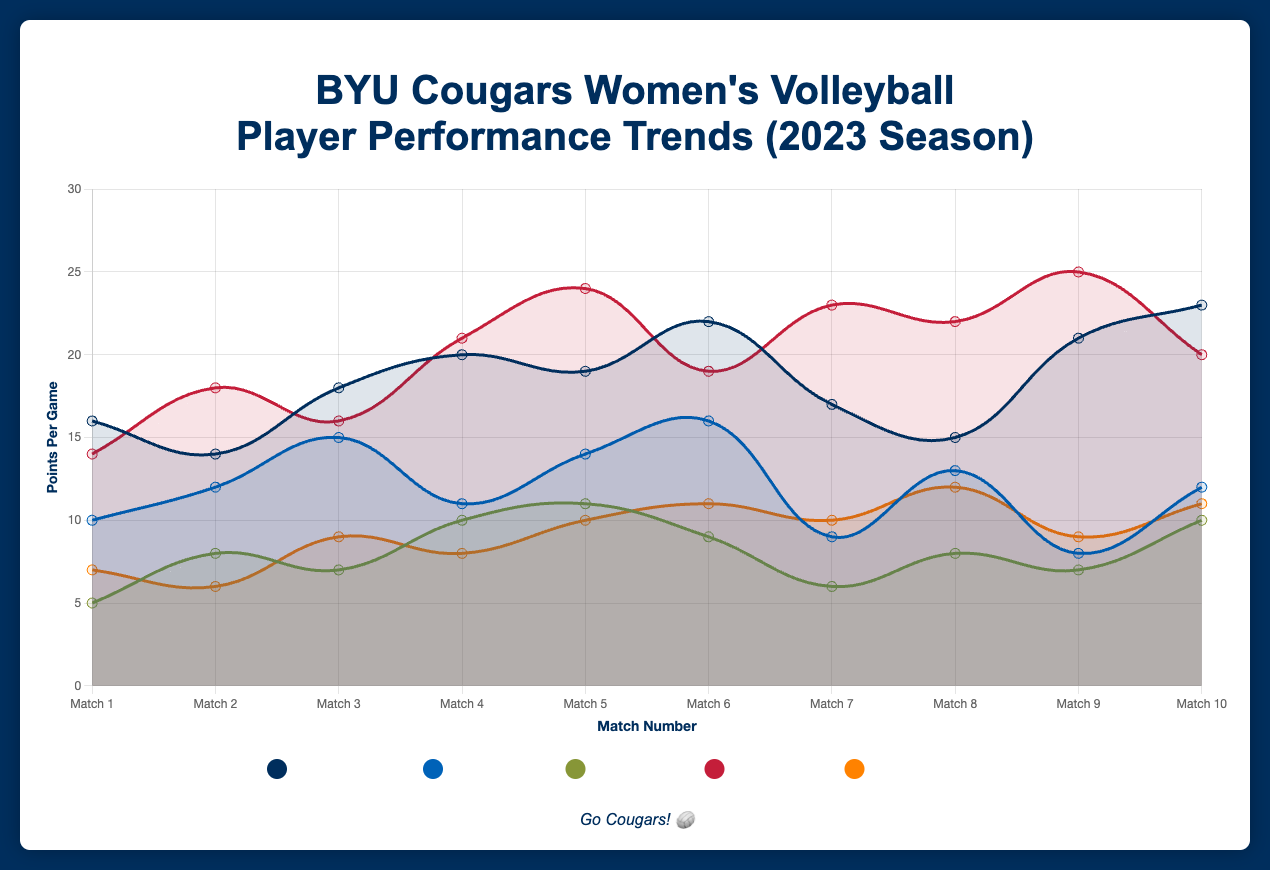Which player scored the highest points in a single match? Identify the highest points scored among all matches: Heather Gneiting's highest is 23, Whitney Bower's is 16, Morgan Bower's is 11, Erin Livingston's is 25, Heather Ballinger's is 12. Erin Livingston scored the highest points in a single match.
Answer: Erin Livingston Which player's points are the most consistent throughout the season? Consistency can be inferred from the smoothness and closeness of points across matches. Heather Ballinger's points range from 6 to 12 with little variation, whereas other players have more significant fluctuations.
Answer: Heather Ballinger What is the average number of points per game for Erin Livingston? Add up all points Erin Livingston scored and divide by the number of matches. Sum: 14+18+16+21+24+19+23+22+25+20 = 202. Average = 202 / 10 = 20.2.
Answer: 20.2 Between Heather Gneiting and Whitney Bower, who had more matches with points 15 or above? Count matches with points 15 or above for both. Heather Gneiting: 9 out of 10; Whitney Bower: 6 out of 10.
Answer: Heather Gneiting Which match had the most total points scored among all players? Sum points for each match across all players. For example, Match 1: 16+10+5+14+7 = 52. Repeat for matches 2-10 and compare. Match 9 has 21+8+7+25+9 = 70, which is the highest.
Answer: Match 9 Who had a higher peak score, Heather Gneiting or Morgan Bower? Compare their highest single match scores. Heather Gneiting's highest is 23, and Morgan Bower's highest is 11. Heather Gneiting had a higher peak score.
Answer: Heather Gneiting How many matches did Erin Livingston score 20 or more points? Count matches where Erin Livingston's points are 20 or above: Matches 4, 5, 7, 8, 9, 10. Total count is 6.
Answer: 6 Which player's performance improved the most by the final match compared to their first match? Calculate the difference in points between match 10 and match 1 for each player. Heather Gneiting: 23-16=7, Whitney Bower: 12-10=2, Morgan Bower: 10-5=5, Erin Livingston: 20-14=6, Heather Ballinger: 11-7=4. Heather Gneiting improved the most with a difference of 7 points.
Answer: Heather Gneiting Between Whitney Bower and Heather Ballinger, who had more matches scoring below 10 points? Whitney Bower has matches 1, 7, 9 below 10 (3 matches). Heather Ballinger has matches 1, 2, 4, 9 below 10 (4 matches). Heather Ballinger had more matches scoring below 10 points.
Answer: Heather Ballinger 